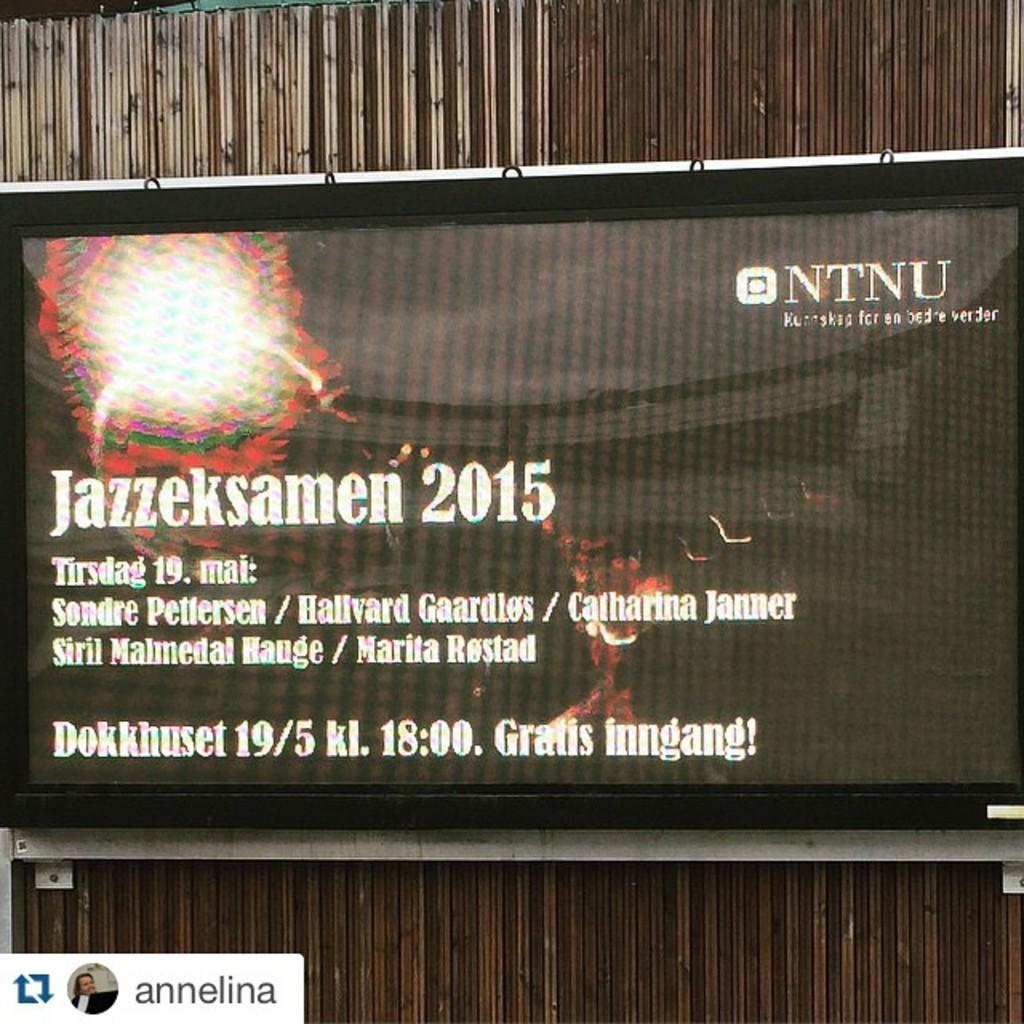<image>
Summarize the visual content of the image. a screen that has the year 2015 on it 